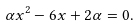Convert formula to latex. <formula><loc_0><loc_0><loc_500><loc_500>\alpha x ^ { 2 } - 6 x + 2 \alpha = 0 .</formula> 